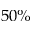<formula> <loc_0><loc_0><loc_500><loc_500>5 0 \%</formula> 